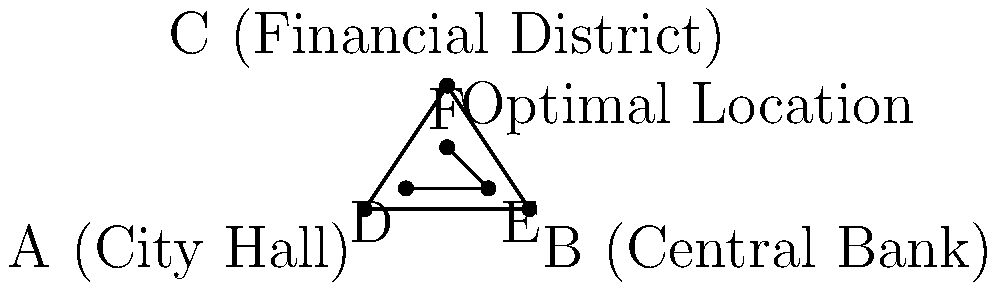As the mayor, you're working with a brokerage firm to determine the optimal location for their new branch. The city has three main financial centers: City Hall (A), Central Bank (B), and the Financial District (C). Using the principle of the centroid of a triangle, where should the new branch be located to minimize the total distance from all three centers? What are the coordinates of this optimal location? To find the optimal location for the new branch, we'll use the concept of the centroid of a triangle. The centroid is the point where the medians of a triangle intersect, and it minimizes the sum of distances to all vertices.

Step 1: Identify the coordinates of the three financial centers:
A (City Hall): (0, 0)
B (Central Bank): (8, 0)
C (Financial District): (4, 6)

Step 2: Calculate the coordinates of the centroid using the formula:
$$(x_centroid, y_centroid) = (\frac{x_A + x_B + x_C}{3}, \frac{y_A + y_B + y_C}{3})$$

Step 3: Substitute the values:
$$x_centroid = \frac{0 + 8 + 4}{3} = \frac{12}{3} = 4$$
$$y_centroid = \frac{0 + 0 + 6}{3} = \frac{6}{3} = 2$$

Step 4: Round the results to the nearest whole number (for practical purposes):
Optimal location: (4, 2)

This point F(4, 2) represents the location that minimizes the total distance from all three financial centers, making it the ideal spot for the new brokerage branch.
Answer: (4, 2) 